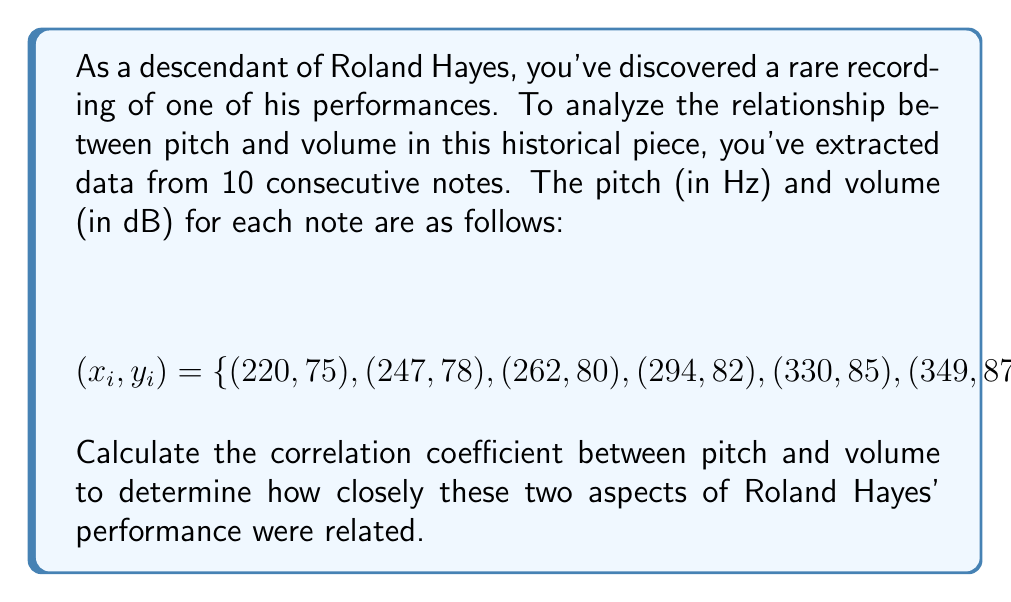Show me your answer to this math problem. To compute the correlation coefficient between pitch (x) and volume (y), we'll use the formula:

$$r = \frac{\sum_{i=1}^{n} (x_i - \bar{x})(y_i - \bar{y})}{\sqrt{\sum_{i=1}^{n} (x_i - \bar{x})^2 \sum_{i=1}^{n} (y_i - \bar{y})^2}}$$

Step 1: Calculate the means $\bar{x}$ and $\bar{y}$
$$\bar{x} = \frac{220 + 247 + 262 + 294 + 330 + 349 + 392 + 440 + 494 + 523}{10} = 355.1$$
$$\bar{y} = \frac{75 + 78 + 80 + 82 + 85 + 87 + 90 + 92 + 95 + 97}{10} = 86.1$$

Step 2: Calculate $(x_i - \bar{x})$, $(y_i - \bar{y})$, $(x_i - \bar{x})^2$, $(y_i - \bar{y})^2$, and $(x_i - \bar{x})(y_i - \bar{y})$ for each pair

Step 3: Sum up the products and squares
$$\sum (x_i - \bar{x})(y_i - \bar{y}) = 28,389.9$$
$$\sum (x_i - \bar{x})^2 = 178,634.9$$
$$\sum (y_i - \bar{y})^2 = 449.9$$

Step 4: Apply the correlation coefficient formula
$$r = \frac{28,389.9}{\sqrt{178,634.9 \times 449.9}} \approx 0.9988$$
Answer: $r \approx 0.9988$ 